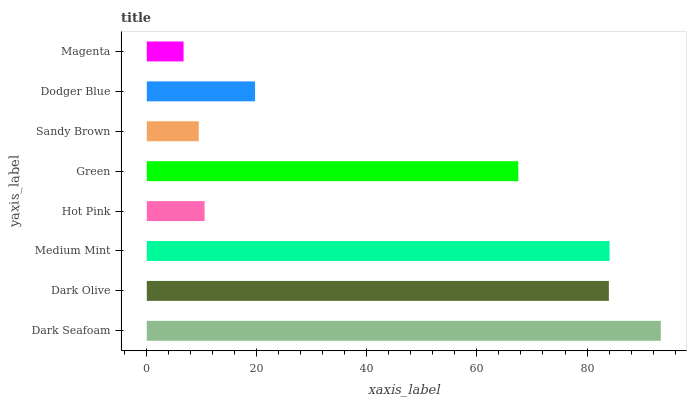Is Magenta the minimum?
Answer yes or no. Yes. Is Dark Seafoam the maximum?
Answer yes or no. Yes. Is Dark Olive the minimum?
Answer yes or no. No. Is Dark Olive the maximum?
Answer yes or no. No. Is Dark Seafoam greater than Dark Olive?
Answer yes or no. Yes. Is Dark Olive less than Dark Seafoam?
Answer yes or no. Yes. Is Dark Olive greater than Dark Seafoam?
Answer yes or no. No. Is Dark Seafoam less than Dark Olive?
Answer yes or no. No. Is Green the high median?
Answer yes or no. Yes. Is Dodger Blue the low median?
Answer yes or no. Yes. Is Dark Seafoam the high median?
Answer yes or no. No. Is Hot Pink the low median?
Answer yes or no. No. 